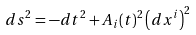Convert formula to latex. <formula><loc_0><loc_0><loc_500><loc_500>d s ^ { 2 } = - d t ^ { 2 } + A _ { i } ( t ) ^ { 2 } \left ( d x ^ { i } \right ) ^ { 2 }</formula> 